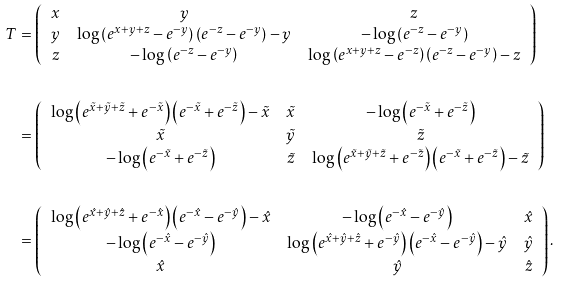Convert formula to latex. <formula><loc_0><loc_0><loc_500><loc_500>T & = \left ( \begin{array} { c c c } x & y & z \\ y & \log \left ( e ^ { x + y + z } - e ^ { - y } \right ) \left ( e ^ { - z } - e ^ { - y } \right ) - y & - \log \left ( e ^ { - z } - e ^ { - y } \right ) \\ z & - \log \left ( e ^ { - z } - e ^ { - y } \right ) & \log \left ( e ^ { x + y + z } - e ^ { - z } \right ) \left ( e ^ { - z } - e ^ { - y } \right ) - z \end{array} \right ) \\ \\ & = \left ( \begin{array} { c c c } \log \left ( e ^ { \tilde { x } + \tilde { y } + \tilde { z } } + e ^ { - \tilde { x } } \right ) \left ( e ^ { - \tilde { x } } + e ^ { - \tilde { z } } \right ) - \tilde { x } & \tilde { x } & - \log \left ( e ^ { - \tilde { x } } + e ^ { - \tilde { z } } \right ) \\ \tilde { x } & \tilde { y } & \tilde { z } \\ - \log \left ( e ^ { - \tilde { x } } + e ^ { - \tilde { z } } \right ) & \tilde { z } & \log \left ( e ^ { \tilde { x } + \tilde { y } + \tilde { z } } + e ^ { - \tilde { z } } \right ) \left ( e ^ { - \tilde { x } } + e ^ { - \tilde { z } } \right ) - \tilde { z } \end{array} \right ) \\ \\ & = \left ( \begin{array} { c c c } \log \left ( e ^ { \hat { x } + \hat { y } + \hat { z } } + e ^ { - \hat { x } } \right ) \left ( e ^ { - \hat { x } } - e ^ { - \hat { y } } \right ) - \hat { x } & - \log \left ( e ^ { - \hat { x } } - e ^ { - \hat { y } } \right ) & \hat { x } \\ - \log \left ( e ^ { - \hat { x } } - e ^ { - \hat { y } } \right ) & \log \left ( e ^ { \hat { x } + \hat { y } + \hat { z } } + e ^ { - \hat { y } } \right ) \left ( e ^ { - \hat { x } } - e ^ { - \hat { y } } \right ) - \hat { y } & \hat { y } \\ \hat { x } & \hat { y } & \hat { z } \end{array} \right ) .</formula> 